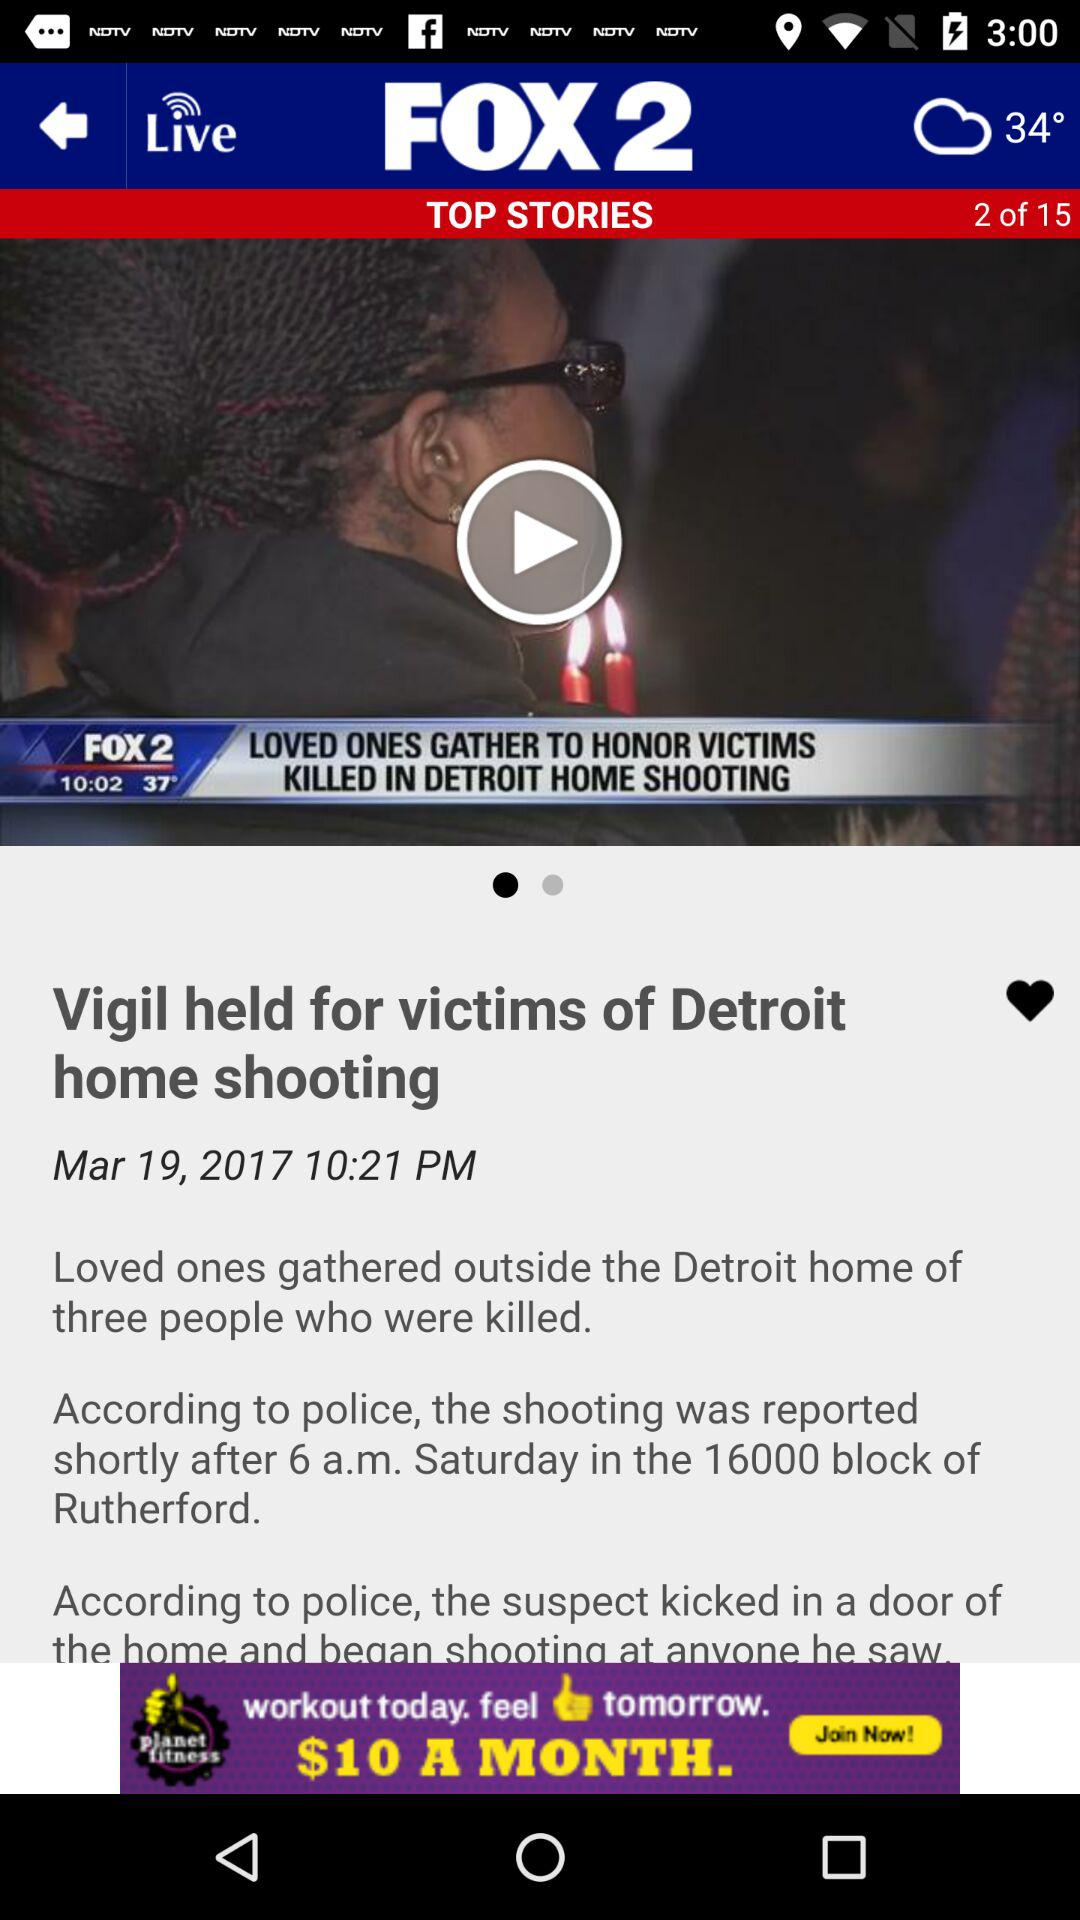At what story is the person currently? The person is at story 2. 